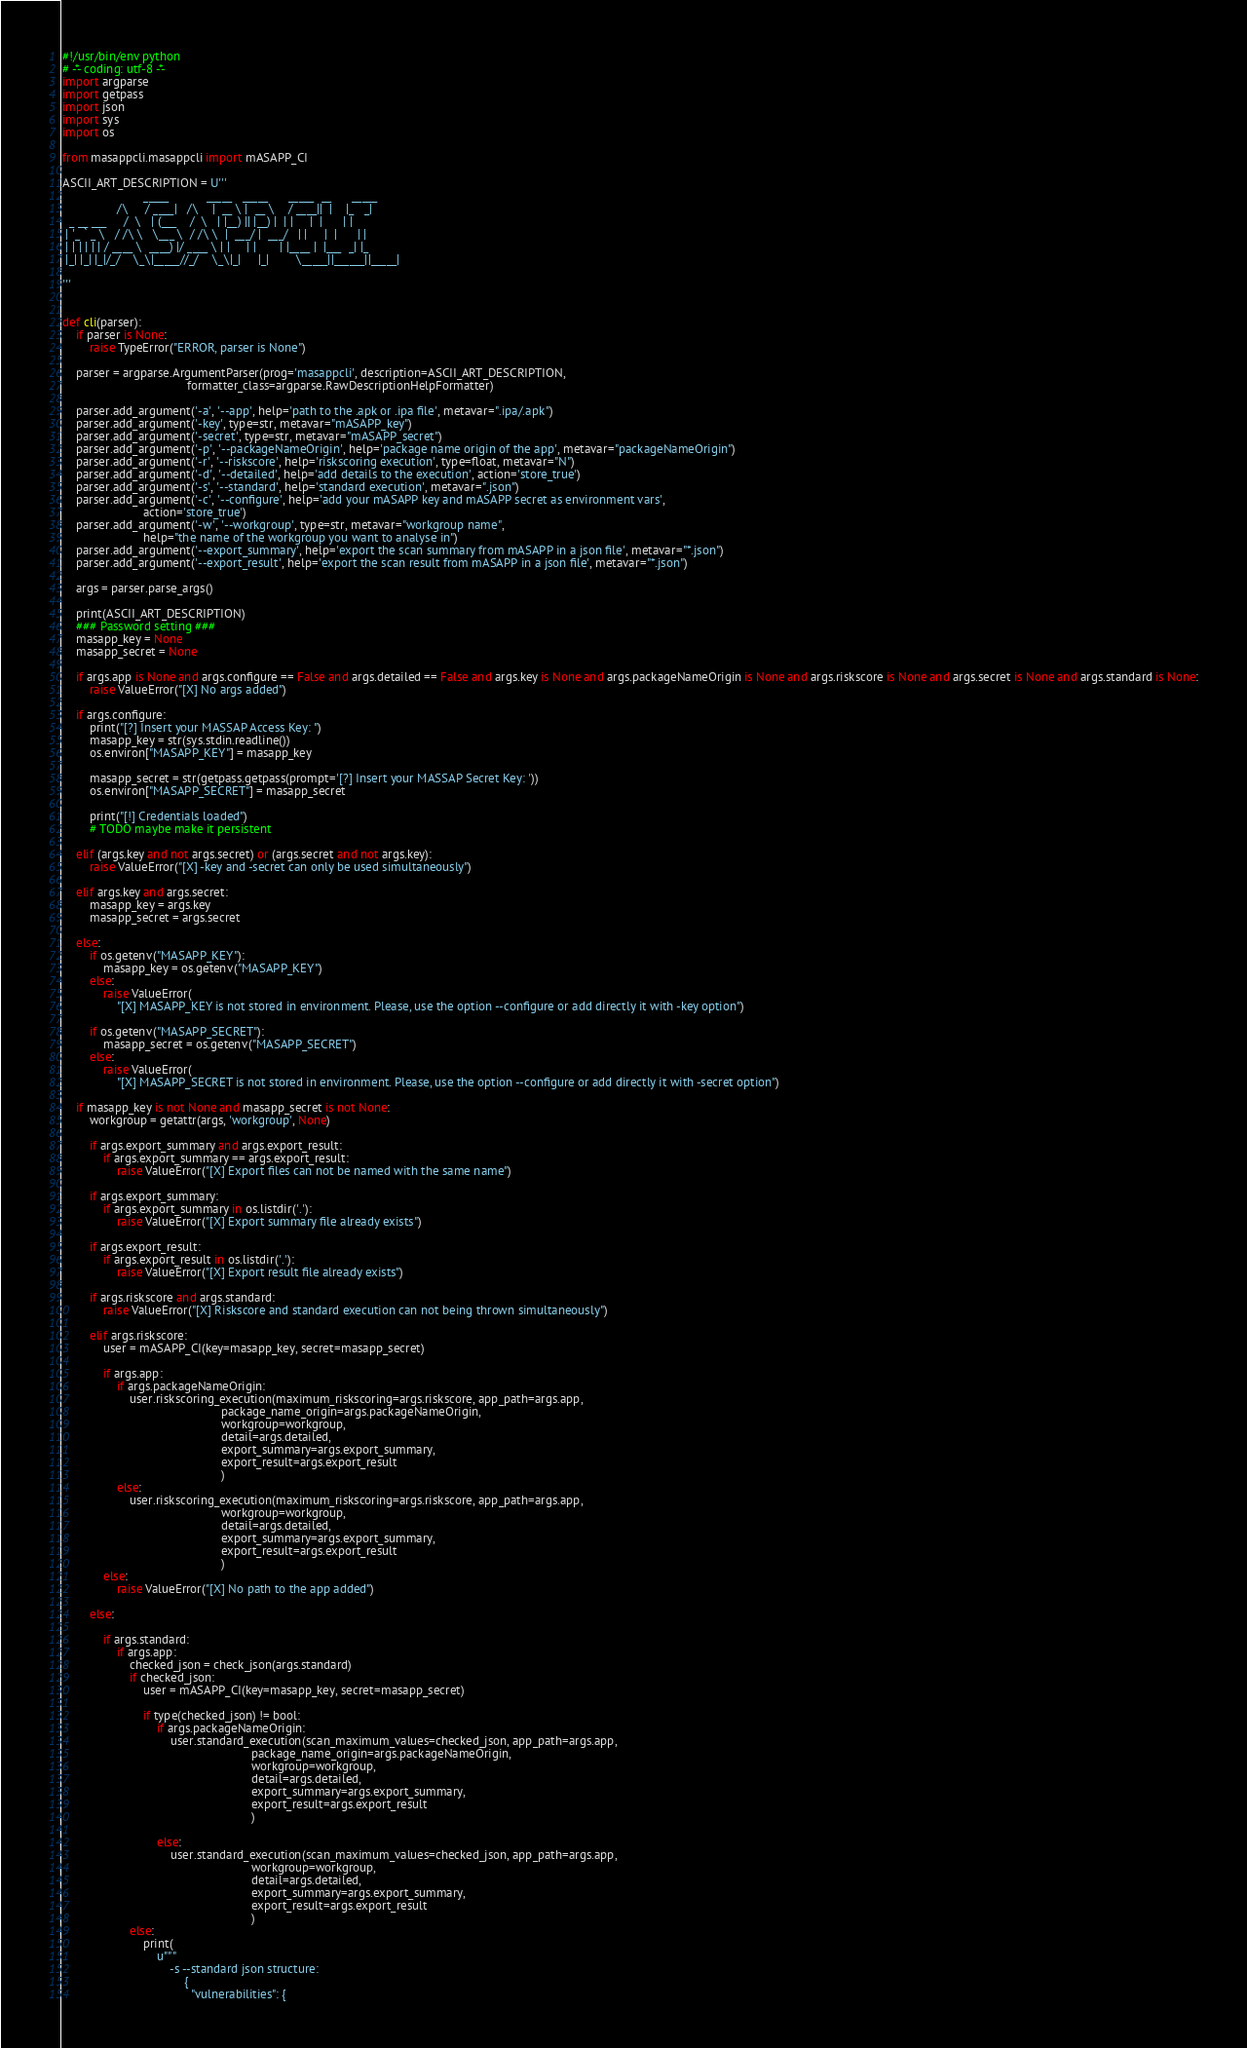Convert code to text. <code><loc_0><loc_0><loc_500><loc_500><_Python_>#!/usr/bin/env python
# -*- coding: utf-8 -*-
import argparse
import getpass
import json
import sys
import os

from masappcli.masappcli import mASAPP_CI

ASCII_ART_DESCRIPTION = U'''
                        _____           _____   _____      _____  __      _____   
                /\     / ____|   /\    |  __ \ |  __ \    / ____||  |    |_   _|  
  _ __ ___     /  \   | (___    /  \   | |__) || |__) |  | |     |  |      | |    
 | '_ ` _ \   / /\ \   \___ \  / /\ \  |  ___/ |  ___/   | |     |  |      | |    
 | | | | | | / ____ \  ____) |/ ____ \ | |     | |       | |____ |  |___  _| |_   
 |_| |_| |_|/_/    \_\|_____//_/    \_\|_|     |_|        \_____||______||_____|  

'''


def cli(parser):
    if parser is None:
        raise TypeError("ERROR, parser is None")

    parser = argparse.ArgumentParser(prog='masappcli', description=ASCII_ART_DESCRIPTION,
                                     formatter_class=argparse.RawDescriptionHelpFormatter)

    parser.add_argument('-a', '--app', help='path to the .apk or .ipa file', metavar=".ipa/.apk")
    parser.add_argument('-key', type=str, metavar="mASAPP_key")
    parser.add_argument('-secret', type=str, metavar="mASAPP_secret")
    parser.add_argument('-p', '--packageNameOrigin', help='package name origin of the app', metavar="packageNameOrigin")
    parser.add_argument('-r', '--riskscore', help='riskscoring execution', type=float, metavar="N")
    parser.add_argument('-d', '--detailed', help='add details to the execution', action='store_true')
    parser.add_argument('-s', '--standard', help='standard execution', metavar=".json")
    parser.add_argument('-c', '--configure', help='add your mASAPP key and mASAPP secret as environment vars',
                        action='store_true')
    parser.add_argument('-w', '--workgroup', type=str, metavar="workgroup name",
                        help="the name of the workgroup you want to analyse in")
    parser.add_argument('--export_summary', help='export the scan summary from mASAPP in a json file', metavar="*.json")
    parser.add_argument('--export_result', help='export the scan result from mASAPP in a json file', metavar="*.json")

    args = parser.parse_args()

    print(ASCII_ART_DESCRIPTION)
    ### Password setting ###
    masapp_key = None
    masapp_secret = None

    if args.app is None and args.configure == False and args.detailed == False and args.key is None and args.packageNameOrigin is None and args.riskscore is None and args.secret is None and args.standard is None:
        raise ValueError("[X] No args added")

    if args.configure:
        print("[?] Insert your MASSAP Access Key: ")
        masapp_key = str(sys.stdin.readline())
        os.environ["MASAPP_KEY"] = masapp_key

        masapp_secret = str(getpass.getpass(prompt='[?] Insert your MASSAP Secret Key: '))
        os.environ["MASAPP_SECRET"] = masapp_secret

        print("[!] Credentials loaded")
        # TODO maybe make it persistent

    elif (args.key and not args.secret) or (args.secret and not args.key):
        raise ValueError("[X] -key and -secret can only be used simultaneously")

    elif args.key and args.secret:
        masapp_key = args.key
        masapp_secret = args.secret

    else:
        if os.getenv("MASAPP_KEY"):
            masapp_key = os.getenv("MASAPP_KEY")
        else:
            raise ValueError(
                "[X] MASAPP_KEY is not stored in environment. Please, use the option --configure or add directly it with -key option")

        if os.getenv("MASAPP_SECRET"):
            masapp_secret = os.getenv("MASAPP_SECRET")
        else:
            raise ValueError(
                "[X] MASAPP_SECRET is not stored in environment. Please, use the option --configure or add directly it with -secret option")

    if masapp_key is not None and masapp_secret is not None:
        workgroup = getattr(args, 'workgroup', None)

        if args.export_summary and args.export_result:
            if args.export_summary == args.export_result:
                raise ValueError("[X] Export files can not be named with the same name")

        if args.export_summary:
            if args.export_summary in os.listdir('.'):
                raise ValueError("[X] Export summary file already exists")

        if args.export_result:
            if args.export_result in os.listdir('.'):
                raise ValueError("[X] Export result file already exists")

        if args.riskscore and args.standard:
            raise ValueError("[X] Riskscore and standard execution can not being thrown simultaneously")

        elif args.riskscore:
            user = mASAPP_CI(key=masapp_key, secret=masapp_secret)

            if args.app:
                if args.packageNameOrigin:
                    user.riskscoring_execution(maximum_riskscoring=args.riskscore, app_path=args.app,
                                               package_name_origin=args.packageNameOrigin,
                                               workgroup=workgroup,
                                               detail=args.detailed,
                                               export_summary=args.export_summary,
                                               export_result=args.export_result
                                               )
                else:
                    user.riskscoring_execution(maximum_riskscoring=args.riskscore, app_path=args.app,
                                               workgroup=workgroup,
                                               detail=args.detailed,
                                               export_summary=args.export_summary,
                                               export_result=args.export_result
                                               )
            else:
                raise ValueError("[X] No path to the app added")

        else:

            if args.standard:
                if args.app:
                    checked_json = check_json(args.standard)
                    if checked_json:
                        user = mASAPP_CI(key=masapp_key, secret=masapp_secret)

                        if type(checked_json) != bool:
                            if args.packageNameOrigin:
                                user.standard_execution(scan_maximum_values=checked_json, app_path=args.app,
                                                        package_name_origin=args.packageNameOrigin,
                                                        workgroup=workgroup,
                                                        detail=args.detailed,
                                                        export_summary=args.export_summary,
                                                        export_result=args.export_result
                                                        )

                            else:
                                user.standard_execution(scan_maximum_values=checked_json, app_path=args.app,
                                                        workgroup=workgroup,
                                                        detail=args.detailed,
                                                        export_summary=args.export_summary,
                                                        export_result=args.export_result
                                                        )
                    else:
                        print(
                            u"""
                                -s --standard json structure:
                                    {
                                      "vulnerabilities": {</code> 